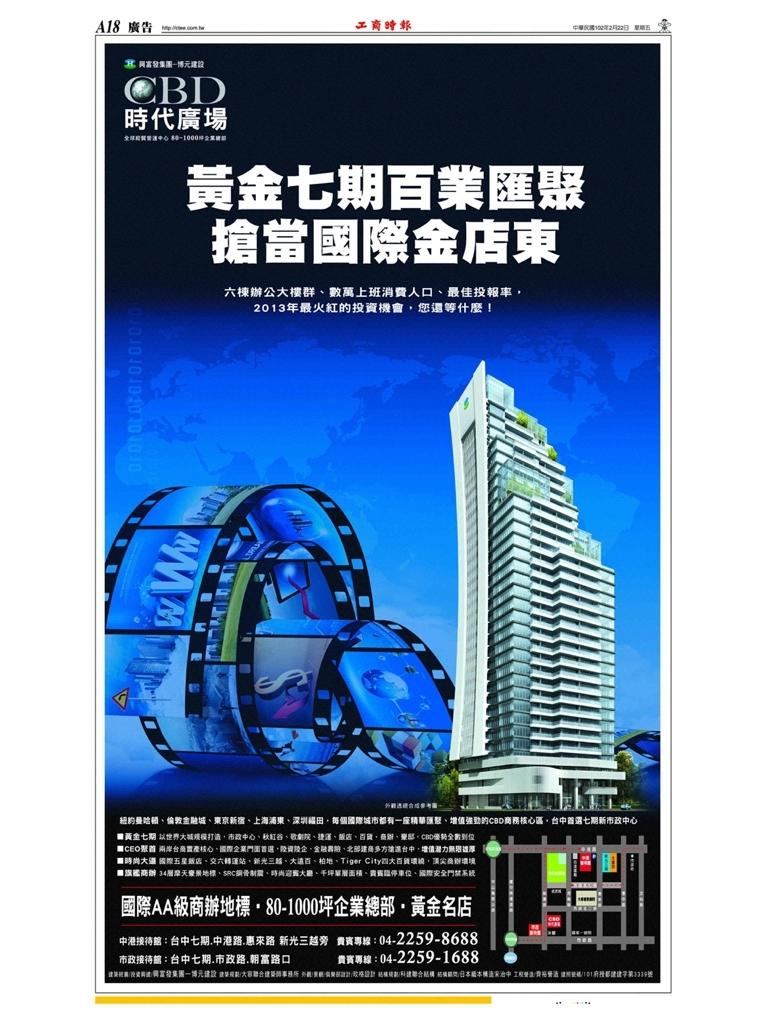Provide a one-sentence caption for the provided image. An advertisement that says CBD on top of it and has a building and other words written in what appears to be Chinese. 